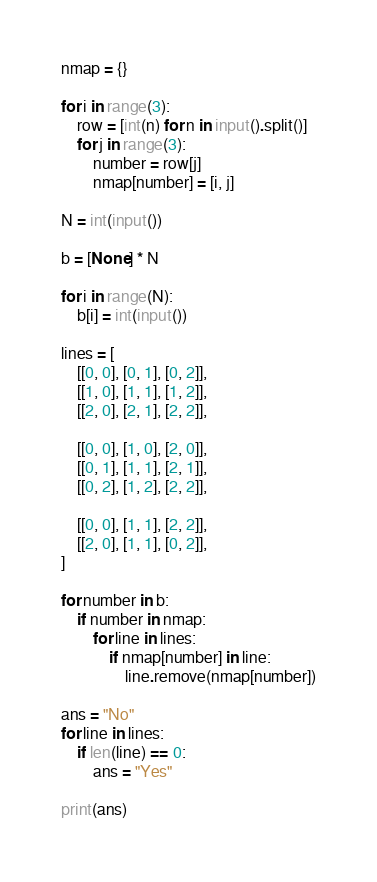Convert code to text. <code><loc_0><loc_0><loc_500><loc_500><_Python_>nmap = {}

for i in range(3):
    row = [int(n) for n in input().split()]
    for j in range(3):
        number = row[j]
        nmap[number] = [i, j]

N = int(input())

b = [None] * N

for i in range(N):
    b[i] = int(input())

lines = [
    [[0, 0], [0, 1], [0, 2]],
    [[1, 0], [1, 1], [1, 2]],
    [[2, 0], [2, 1], [2, 2]],

    [[0, 0], [1, 0], [2, 0]],
    [[0, 1], [1, 1], [2, 1]],
    [[0, 2], [1, 2], [2, 2]],

    [[0, 0], [1, 1], [2, 2]],
    [[2, 0], [1, 1], [0, 2]],
]

for number in b:
    if number in nmap:
        for line in lines:
            if nmap[number] in line:
                line.remove(nmap[number])

ans = "No"
for line in lines:
    if len(line) == 0:
        ans = "Yes"

print(ans)</code> 